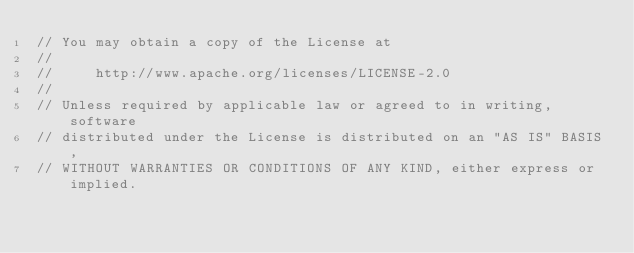<code> <loc_0><loc_0><loc_500><loc_500><_C++_>// You may obtain a copy of the License at
//
//     http://www.apache.org/licenses/LICENSE-2.0
//
// Unless required by applicable law or agreed to in writing, software
// distributed under the License is distributed on an "AS IS" BASIS,
// WITHOUT WARRANTIES OR CONDITIONS OF ANY KIND, either express or implied.</code> 